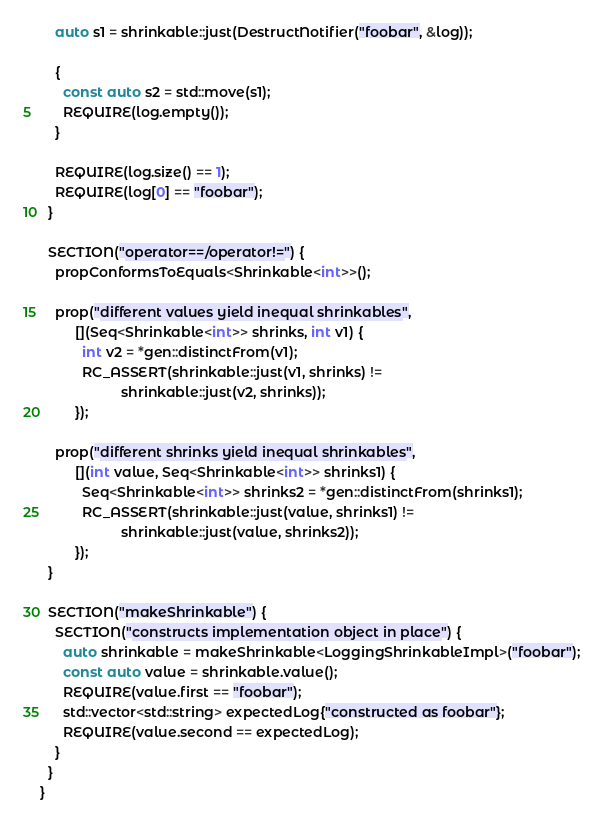<code> <loc_0><loc_0><loc_500><loc_500><_C++_>    auto s1 = shrinkable::just(DestructNotifier("foobar", &log));

    {
      const auto s2 = std::move(s1);
      REQUIRE(log.empty());
    }

    REQUIRE(log.size() == 1);
    REQUIRE(log[0] == "foobar");
  }

  SECTION("operator==/operator!=") {
    propConformsToEquals<Shrinkable<int>>();

    prop("different values yield inequal shrinkables",
         [](Seq<Shrinkable<int>> shrinks, int v1) {
           int v2 = *gen::distinctFrom(v1);
           RC_ASSERT(shrinkable::just(v1, shrinks) !=
                     shrinkable::just(v2, shrinks));
         });

    prop("different shrinks yield inequal shrinkables",
         [](int value, Seq<Shrinkable<int>> shrinks1) {
           Seq<Shrinkable<int>> shrinks2 = *gen::distinctFrom(shrinks1);
           RC_ASSERT(shrinkable::just(value, shrinks1) !=
                     shrinkable::just(value, shrinks2));
         });
  }

  SECTION("makeShrinkable") {
    SECTION("constructs implementation object in place") {
      auto shrinkable = makeShrinkable<LoggingShrinkableImpl>("foobar");
      const auto value = shrinkable.value();
      REQUIRE(value.first == "foobar");
      std::vector<std::string> expectedLog{"constructed as foobar"};
      REQUIRE(value.second == expectedLog);
    }
  }
}
</code> 